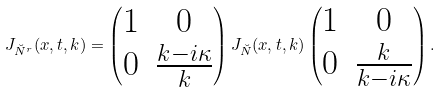Convert formula to latex. <formula><loc_0><loc_0><loc_500><loc_500>J _ { \breve { N } ^ { r } } ( x , t , k ) = \begin{pmatrix} 1 & 0 \\ 0 & \frac { k - i \kappa } { k } \end{pmatrix} J _ { \breve { N } } ( x , t , k ) \begin{pmatrix} 1 & 0 \\ 0 & \frac { k } { k - i \kappa } \end{pmatrix} .</formula> 